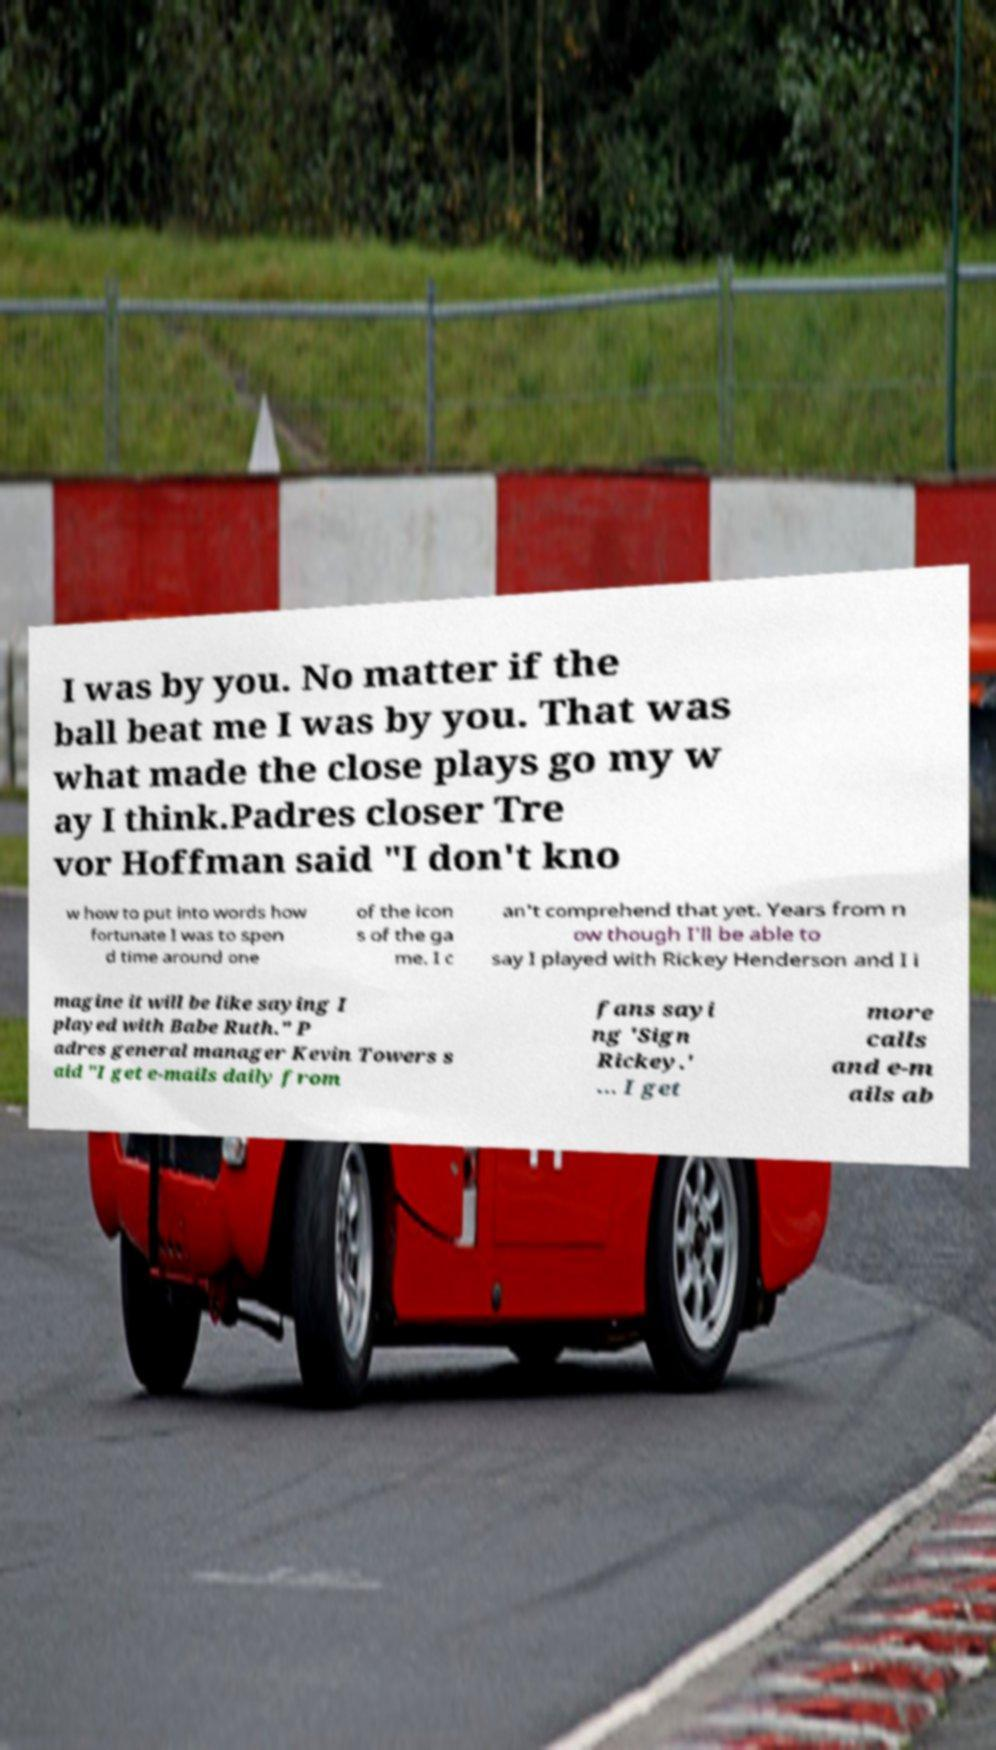There's text embedded in this image that I need extracted. Can you transcribe it verbatim? I was by you. No matter if the ball beat me I was by you. That was what made the close plays go my w ay I think.Padres closer Tre vor Hoffman said "I don't kno w how to put into words how fortunate I was to spen d time around one of the icon s of the ga me. I c an't comprehend that yet. Years from n ow though I'll be able to say I played with Rickey Henderson and I i magine it will be like saying I played with Babe Ruth." P adres general manager Kevin Towers s aid "I get e-mails daily from fans sayi ng 'Sign Rickey.' ... I get more calls and e-m ails ab 